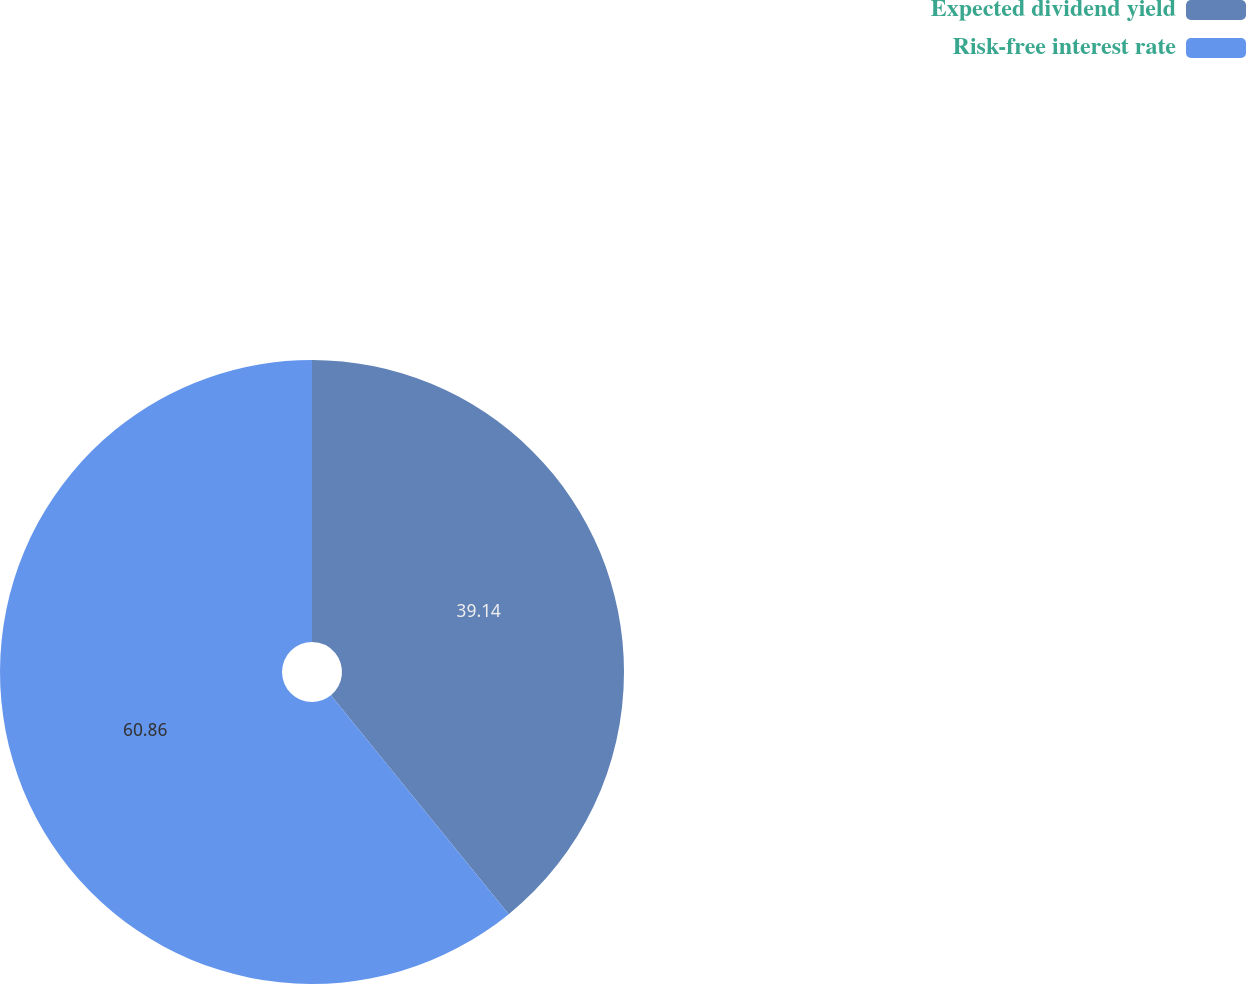Convert chart. <chart><loc_0><loc_0><loc_500><loc_500><pie_chart><fcel>Expected dividend yield<fcel>Risk-free interest rate<nl><fcel>39.14%<fcel>60.86%<nl></chart> 